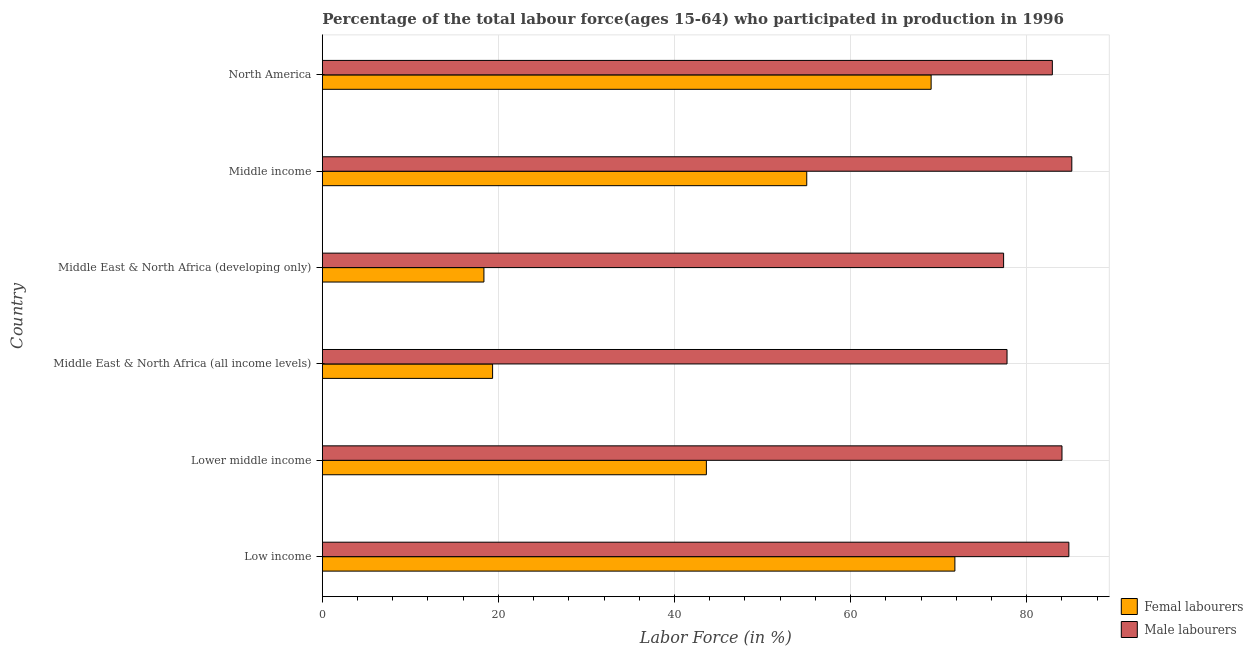How many bars are there on the 2nd tick from the top?
Provide a succinct answer. 2. How many bars are there on the 5th tick from the bottom?
Provide a short and direct response. 2. In how many cases, is the number of bars for a given country not equal to the number of legend labels?
Your response must be concise. 0. What is the percentage of female labor force in Middle East & North Africa (all income levels)?
Ensure brevity in your answer.  19.34. Across all countries, what is the maximum percentage of female labor force?
Your answer should be very brief. 71.85. Across all countries, what is the minimum percentage of female labor force?
Ensure brevity in your answer.  18.35. In which country was the percentage of female labor force minimum?
Your answer should be compact. Middle East & North Africa (developing only). What is the total percentage of female labor force in the graph?
Make the answer very short. 277.33. What is the difference between the percentage of male labour force in Lower middle income and that in Middle East & North Africa (developing only)?
Your answer should be compact. 6.63. What is the difference between the percentage of male labour force in Middle East & North Africa (all income levels) and the percentage of female labor force in Low income?
Your answer should be very brief. 5.92. What is the average percentage of male labour force per country?
Your answer should be compact. 82. What is the difference between the percentage of female labor force and percentage of male labour force in North America?
Your response must be concise. -13.77. In how many countries, is the percentage of male labour force greater than 16 %?
Your answer should be very brief. 6. What is the ratio of the percentage of female labor force in Lower middle income to that in Middle East & North Africa (developing only)?
Provide a short and direct response. 2.38. Is the percentage of female labor force in Lower middle income less than that in Middle East & North Africa (developing only)?
Make the answer very short. No. Is the difference between the percentage of female labor force in Middle income and North America greater than the difference between the percentage of male labour force in Middle income and North America?
Your response must be concise. No. What is the difference between the highest and the second highest percentage of male labour force?
Keep it short and to the point. 0.34. What is the difference between the highest and the lowest percentage of female labor force?
Keep it short and to the point. 53.49. In how many countries, is the percentage of female labor force greater than the average percentage of female labor force taken over all countries?
Offer a very short reply. 3. Is the sum of the percentage of female labor force in Middle East & North Africa (all income levels) and North America greater than the maximum percentage of male labour force across all countries?
Your response must be concise. Yes. What does the 1st bar from the top in Lower middle income represents?
Give a very brief answer. Male labourers. What does the 2nd bar from the bottom in Lower middle income represents?
Offer a terse response. Male labourers. How many countries are there in the graph?
Your answer should be compact. 6. What is the difference between two consecutive major ticks on the X-axis?
Offer a terse response. 20. Are the values on the major ticks of X-axis written in scientific E-notation?
Keep it short and to the point. No. Where does the legend appear in the graph?
Provide a succinct answer. Bottom right. What is the title of the graph?
Offer a very short reply. Percentage of the total labour force(ages 15-64) who participated in production in 1996. Does "Highest 20% of population" appear as one of the legend labels in the graph?
Provide a short and direct response. No. What is the label or title of the X-axis?
Provide a short and direct response. Labor Force (in %). What is the label or title of the Y-axis?
Your answer should be very brief. Country. What is the Labor Force (in %) in Femal labourers in Low income?
Ensure brevity in your answer.  71.85. What is the Labor Force (in %) in Male labourers in Low income?
Offer a terse response. 84.79. What is the Labor Force (in %) in Femal labourers in Lower middle income?
Make the answer very short. 43.62. What is the Labor Force (in %) of Male labourers in Lower middle income?
Ensure brevity in your answer.  84.01. What is the Labor Force (in %) in Femal labourers in Middle East & North Africa (all income levels)?
Your answer should be very brief. 19.34. What is the Labor Force (in %) of Male labourers in Middle East & North Africa (all income levels)?
Ensure brevity in your answer.  77.77. What is the Labor Force (in %) in Femal labourers in Middle East & North Africa (developing only)?
Your answer should be compact. 18.35. What is the Labor Force (in %) in Male labourers in Middle East & North Africa (developing only)?
Your response must be concise. 77.38. What is the Labor Force (in %) of Femal labourers in Middle income?
Your response must be concise. 55.02. What is the Labor Force (in %) of Male labourers in Middle income?
Provide a succinct answer. 85.13. What is the Labor Force (in %) of Femal labourers in North America?
Your answer should be compact. 69.15. What is the Labor Force (in %) in Male labourers in North America?
Your response must be concise. 82.92. Across all countries, what is the maximum Labor Force (in %) of Femal labourers?
Provide a short and direct response. 71.85. Across all countries, what is the maximum Labor Force (in %) of Male labourers?
Provide a succinct answer. 85.13. Across all countries, what is the minimum Labor Force (in %) of Femal labourers?
Ensure brevity in your answer.  18.35. Across all countries, what is the minimum Labor Force (in %) of Male labourers?
Offer a terse response. 77.38. What is the total Labor Force (in %) of Femal labourers in the graph?
Make the answer very short. 277.33. What is the total Labor Force (in %) in Male labourers in the graph?
Keep it short and to the point. 491.99. What is the difference between the Labor Force (in %) of Femal labourers in Low income and that in Lower middle income?
Offer a terse response. 28.23. What is the difference between the Labor Force (in %) in Male labourers in Low income and that in Lower middle income?
Offer a terse response. 0.78. What is the difference between the Labor Force (in %) in Femal labourers in Low income and that in Middle East & North Africa (all income levels)?
Your answer should be compact. 52.51. What is the difference between the Labor Force (in %) in Male labourers in Low income and that in Middle East & North Africa (all income levels)?
Your answer should be very brief. 7.02. What is the difference between the Labor Force (in %) of Femal labourers in Low income and that in Middle East & North Africa (developing only)?
Your answer should be very brief. 53.49. What is the difference between the Labor Force (in %) in Male labourers in Low income and that in Middle East & North Africa (developing only)?
Provide a succinct answer. 7.41. What is the difference between the Labor Force (in %) of Femal labourers in Low income and that in Middle income?
Offer a terse response. 16.83. What is the difference between the Labor Force (in %) in Male labourers in Low income and that in Middle income?
Offer a terse response. -0.34. What is the difference between the Labor Force (in %) of Femal labourers in Low income and that in North America?
Provide a succinct answer. 2.7. What is the difference between the Labor Force (in %) in Male labourers in Low income and that in North America?
Provide a short and direct response. 1.87. What is the difference between the Labor Force (in %) in Femal labourers in Lower middle income and that in Middle East & North Africa (all income levels)?
Ensure brevity in your answer.  24.28. What is the difference between the Labor Force (in %) in Male labourers in Lower middle income and that in Middle East & North Africa (all income levels)?
Provide a succinct answer. 6.24. What is the difference between the Labor Force (in %) in Femal labourers in Lower middle income and that in Middle East & North Africa (developing only)?
Give a very brief answer. 25.27. What is the difference between the Labor Force (in %) of Male labourers in Lower middle income and that in Middle East & North Africa (developing only)?
Offer a terse response. 6.63. What is the difference between the Labor Force (in %) in Femal labourers in Lower middle income and that in Middle income?
Your response must be concise. -11.4. What is the difference between the Labor Force (in %) of Male labourers in Lower middle income and that in Middle income?
Ensure brevity in your answer.  -1.12. What is the difference between the Labor Force (in %) of Femal labourers in Lower middle income and that in North America?
Provide a succinct answer. -25.53. What is the difference between the Labor Force (in %) of Male labourers in Lower middle income and that in North America?
Offer a terse response. 1.09. What is the difference between the Labor Force (in %) of Femal labourers in Middle East & North Africa (all income levels) and that in Middle East & North Africa (developing only)?
Keep it short and to the point. 0.99. What is the difference between the Labor Force (in %) in Male labourers in Middle East & North Africa (all income levels) and that in Middle East & North Africa (developing only)?
Offer a very short reply. 0.39. What is the difference between the Labor Force (in %) in Femal labourers in Middle East & North Africa (all income levels) and that in Middle income?
Your answer should be very brief. -35.68. What is the difference between the Labor Force (in %) in Male labourers in Middle East & North Africa (all income levels) and that in Middle income?
Provide a succinct answer. -7.36. What is the difference between the Labor Force (in %) in Femal labourers in Middle East & North Africa (all income levels) and that in North America?
Provide a short and direct response. -49.81. What is the difference between the Labor Force (in %) in Male labourers in Middle East & North Africa (all income levels) and that in North America?
Your response must be concise. -5.15. What is the difference between the Labor Force (in %) of Femal labourers in Middle East & North Africa (developing only) and that in Middle income?
Keep it short and to the point. -36.67. What is the difference between the Labor Force (in %) in Male labourers in Middle East & North Africa (developing only) and that in Middle income?
Keep it short and to the point. -7.75. What is the difference between the Labor Force (in %) in Femal labourers in Middle East & North Africa (developing only) and that in North America?
Your response must be concise. -50.79. What is the difference between the Labor Force (in %) of Male labourers in Middle East & North Africa (developing only) and that in North America?
Your response must be concise. -5.54. What is the difference between the Labor Force (in %) of Femal labourers in Middle income and that in North America?
Your response must be concise. -14.13. What is the difference between the Labor Force (in %) in Male labourers in Middle income and that in North America?
Your answer should be very brief. 2.21. What is the difference between the Labor Force (in %) of Femal labourers in Low income and the Labor Force (in %) of Male labourers in Lower middle income?
Your answer should be very brief. -12.16. What is the difference between the Labor Force (in %) of Femal labourers in Low income and the Labor Force (in %) of Male labourers in Middle East & North Africa (all income levels)?
Give a very brief answer. -5.92. What is the difference between the Labor Force (in %) in Femal labourers in Low income and the Labor Force (in %) in Male labourers in Middle East & North Africa (developing only)?
Ensure brevity in your answer.  -5.53. What is the difference between the Labor Force (in %) of Femal labourers in Low income and the Labor Force (in %) of Male labourers in Middle income?
Give a very brief answer. -13.28. What is the difference between the Labor Force (in %) of Femal labourers in Low income and the Labor Force (in %) of Male labourers in North America?
Keep it short and to the point. -11.07. What is the difference between the Labor Force (in %) in Femal labourers in Lower middle income and the Labor Force (in %) in Male labourers in Middle East & North Africa (all income levels)?
Your answer should be compact. -34.15. What is the difference between the Labor Force (in %) in Femal labourers in Lower middle income and the Labor Force (in %) in Male labourers in Middle East & North Africa (developing only)?
Keep it short and to the point. -33.76. What is the difference between the Labor Force (in %) in Femal labourers in Lower middle income and the Labor Force (in %) in Male labourers in Middle income?
Your answer should be very brief. -41.51. What is the difference between the Labor Force (in %) of Femal labourers in Lower middle income and the Labor Force (in %) of Male labourers in North America?
Your answer should be compact. -39.3. What is the difference between the Labor Force (in %) in Femal labourers in Middle East & North Africa (all income levels) and the Labor Force (in %) in Male labourers in Middle East & North Africa (developing only)?
Keep it short and to the point. -58.04. What is the difference between the Labor Force (in %) of Femal labourers in Middle East & North Africa (all income levels) and the Labor Force (in %) of Male labourers in Middle income?
Offer a terse response. -65.79. What is the difference between the Labor Force (in %) in Femal labourers in Middle East & North Africa (all income levels) and the Labor Force (in %) in Male labourers in North America?
Your response must be concise. -63.58. What is the difference between the Labor Force (in %) of Femal labourers in Middle East & North Africa (developing only) and the Labor Force (in %) of Male labourers in Middle income?
Your answer should be very brief. -66.77. What is the difference between the Labor Force (in %) in Femal labourers in Middle East & North Africa (developing only) and the Labor Force (in %) in Male labourers in North America?
Offer a very short reply. -64.56. What is the difference between the Labor Force (in %) in Femal labourers in Middle income and the Labor Force (in %) in Male labourers in North America?
Offer a very short reply. -27.89. What is the average Labor Force (in %) in Femal labourers per country?
Make the answer very short. 46.22. What is the average Labor Force (in %) in Male labourers per country?
Your response must be concise. 82. What is the difference between the Labor Force (in %) of Femal labourers and Labor Force (in %) of Male labourers in Low income?
Keep it short and to the point. -12.94. What is the difference between the Labor Force (in %) in Femal labourers and Labor Force (in %) in Male labourers in Lower middle income?
Offer a very short reply. -40.39. What is the difference between the Labor Force (in %) of Femal labourers and Labor Force (in %) of Male labourers in Middle East & North Africa (all income levels)?
Provide a short and direct response. -58.43. What is the difference between the Labor Force (in %) of Femal labourers and Labor Force (in %) of Male labourers in Middle East & North Africa (developing only)?
Provide a succinct answer. -59.03. What is the difference between the Labor Force (in %) in Femal labourers and Labor Force (in %) in Male labourers in Middle income?
Your answer should be very brief. -30.11. What is the difference between the Labor Force (in %) in Femal labourers and Labor Force (in %) in Male labourers in North America?
Keep it short and to the point. -13.77. What is the ratio of the Labor Force (in %) of Femal labourers in Low income to that in Lower middle income?
Offer a very short reply. 1.65. What is the ratio of the Labor Force (in %) of Male labourers in Low income to that in Lower middle income?
Your answer should be very brief. 1.01. What is the ratio of the Labor Force (in %) in Femal labourers in Low income to that in Middle East & North Africa (all income levels)?
Your response must be concise. 3.72. What is the ratio of the Labor Force (in %) in Male labourers in Low income to that in Middle East & North Africa (all income levels)?
Offer a terse response. 1.09. What is the ratio of the Labor Force (in %) of Femal labourers in Low income to that in Middle East & North Africa (developing only)?
Provide a short and direct response. 3.91. What is the ratio of the Labor Force (in %) in Male labourers in Low income to that in Middle East & North Africa (developing only)?
Offer a very short reply. 1.1. What is the ratio of the Labor Force (in %) of Femal labourers in Low income to that in Middle income?
Give a very brief answer. 1.31. What is the ratio of the Labor Force (in %) in Male labourers in Low income to that in Middle income?
Your response must be concise. 1. What is the ratio of the Labor Force (in %) in Femal labourers in Low income to that in North America?
Offer a terse response. 1.04. What is the ratio of the Labor Force (in %) in Male labourers in Low income to that in North America?
Your response must be concise. 1.02. What is the ratio of the Labor Force (in %) in Femal labourers in Lower middle income to that in Middle East & North Africa (all income levels)?
Make the answer very short. 2.26. What is the ratio of the Labor Force (in %) of Male labourers in Lower middle income to that in Middle East & North Africa (all income levels)?
Offer a very short reply. 1.08. What is the ratio of the Labor Force (in %) in Femal labourers in Lower middle income to that in Middle East & North Africa (developing only)?
Offer a very short reply. 2.38. What is the ratio of the Labor Force (in %) in Male labourers in Lower middle income to that in Middle East & North Africa (developing only)?
Your answer should be compact. 1.09. What is the ratio of the Labor Force (in %) in Femal labourers in Lower middle income to that in Middle income?
Provide a succinct answer. 0.79. What is the ratio of the Labor Force (in %) of Male labourers in Lower middle income to that in Middle income?
Provide a succinct answer. 0.99. What is the ratio of the Labor Force (in %) in Femal labourers in Lower middle income to that in North America?
Offer a terse response. 0.63. What is the ratio of the Labor Force (in %) in Male labourers in Lower middle income to that in North America?
Offer a terse response. 1.01. What is the ratio of the Labor Force (in %) of Femal labourers in Middle East & North Africa (all income levels) to that in Middle East & North Africa (developing only)?
Your answer should be compact. 1.05. What is the ratio of the Labor Force (in %) of Femal labourers in Middle East & North Africa (all income levels) to that in Middle income?
Offer a terse response. 0.35. What is the ratio of the Labor Force (in %) in Male labourers in Middle East & North Africa (all income levels) to that in Middle income?
Offer a very short reply. 0.91. What is the ratio of the Labor Force (in %) in Femal labourers in Middle East & North Africa (all income levels) to that in North America?
Provide a short and direct response. 0.28. What is the ratio of the Labor Force (in %) of Male labourers in Middle East & North Africa (all income levels) to that in North America?
Offer a very short reply. 0.94. What is the ratio of the Labor Force (in %) in Femal labourers in Middle East & North Africa (developing only) to that in Middle income?
Provide a short and direct response. 0.33. What is the ratio of the Labor Force (in %) in Male labourers in Middle East & North Africa (developing only) to that in Middle income?
Offer a very short reply. 0.91. What is the ratio of the Labor Force (in %) of Femal labourers in Middle East & North Africa (developing only) to that in North America?
Provide a succinct answer. 0.27. What is the ratio of the Labor Force (in %) in Male labourers in Middle East & North Africa (developing only) to that in North America?
Your answer should be compact. 0.93. What is the ratio of the Labor Force (in %) in Femal labourers in Middle income to that in North America?
Make the answer very short. 0.8. What is the ratio of the Labor Force (in %) of Male labourers in Middle income to that in North America?
Provide a succinct answer. 1.03. What is the difference between the highest and the second highest Labor Force (in %) of Femal labourers?
Keep it short and to the point. 2.7. What is the difference between the highest and the second highest Labor Force (in %) in Male labourers?
Your answer should be compact. 0.34. What is the difference between the highest and the lowest Labor Force (in %) of Femal labourers?
Your response must be concise. 53.49. What is the difference between the highest and the lowest Labor Force (in %) in Male labourers?
Keep it short and to the point. 7.75. 